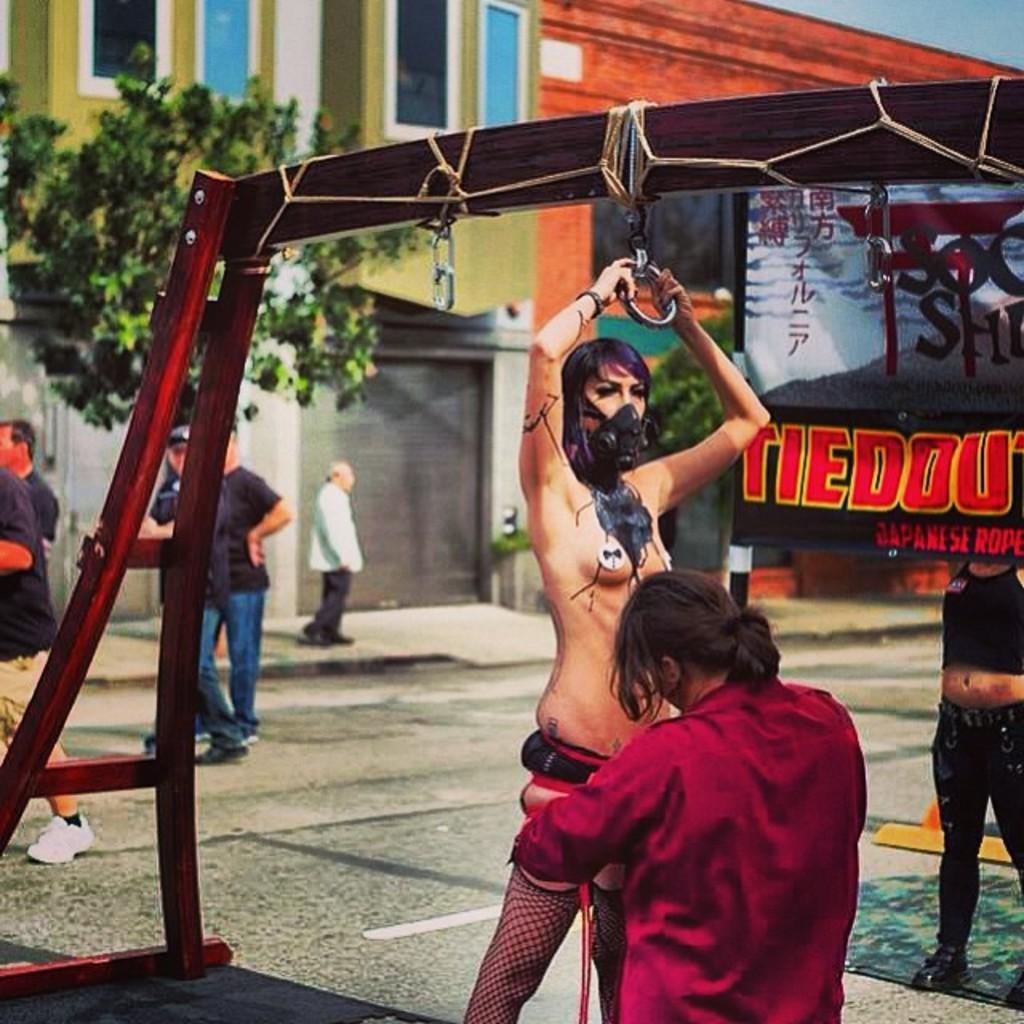Could you give a brief overview of what you see in this image? It looks like an edited image. We can see there is a woman holding an object. Behind the woman, there is a tree, people and a building. On the right side of the image, there is a banner. 